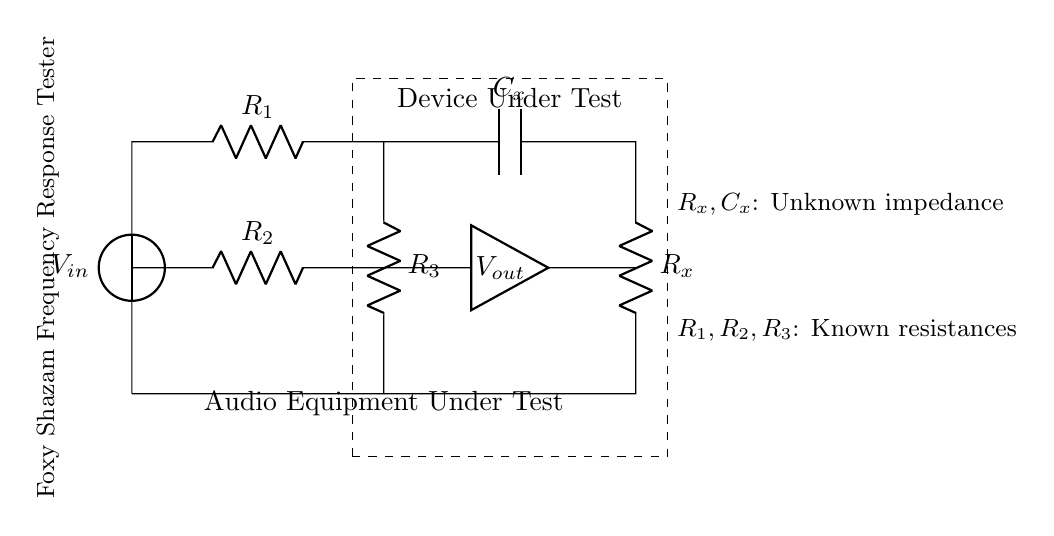What is the input voltage of the circuit? The input voltage is represented as V_in, which is the source voltage applied at the top of the circuit.
Answer: V_in What type of component is C_x? C_x is labeled in the circuit diagram and is identified as a capacitor, which is used to affect the frequency response in the circuit.
Answer: Capacitor How many resistors are in this bridge circuit? By examining the diagram, the three resistors R_1, R_2, and R_3 are visible and labeled, indicating there are three resistors in total.
Answer: 3 What does V_out represent? V_out is marked in the circuit and signifies the output voltage obtained across the audio equipment being tested.
Answer: Output voltage What is the function of the dashed rectangle? The dashed rectangle encloses the section of the circuit indicating the device under test, providing context about what is being measured within the setup.
Answer: Device Under Test What do R_x and C_x represent in the circuit? R_x and C_x are labeled as unknown impedance components contributing to the bridge balance and indicate the parameters of the audio equipment being tested.
Answer: Unknown impedance 